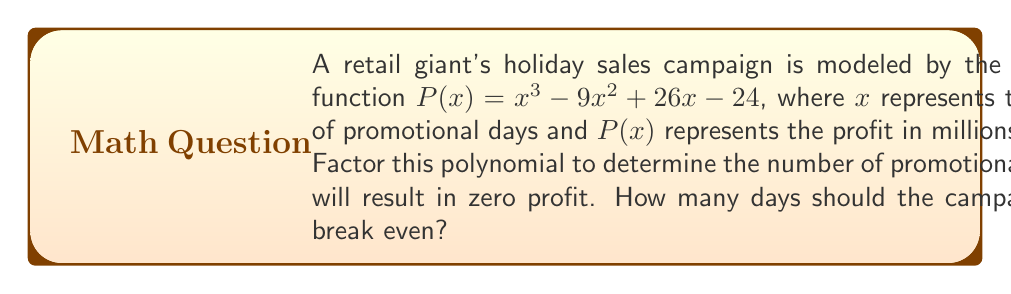Provide a solution to this math problem. To solve this problem, we need to factor the polynomial $P(x) = x^3 - 9x^2 + 26x - 24$ and find its roots. The roots will represent the number of days where the profit is zero (break-even points).

Step 1: Check for a common factor
There is no common factor for all terms.

Step 2: Try to guess one root
By inspection or trial and error, we can find that $x = 2$ is a root of the polynomial.

Step 3: Use polynomial long division to factor out $(x - 2)$
$$\begin{array}{r}
x^2 - 7x + 12 \\
x - 2 \enclose{longdiv}{x^3 - 9x^2 + 26x - 24} \\
\underline{x^3 - 2x^2} \\
-7x^2 + 26x \\
\underline{-7x^2 + 14x} \\
12x - 24 \\
\underline{12x - 24} \\
0
\end{array}$$

So, $P(x) = (x - 2)(x^2 - 7x + 12)$

Step 4: Factor the quadratic term
$x^2 - 7x + 12 = (x - 3)(x - 4)$

Step 5: Write the fully factored polynomial
$P(x) = (x - 2)(x - 3)(x - 4)$

The roots of this polynomial are $x = 2$, $x = 3$, and $x = 4$.

These roots represent the number of promotional days that will result in zero profit (break-even points). The campaign will break even after 2 days, 3 days, or 4 days.
Answer: 2, 3, or 4 days 